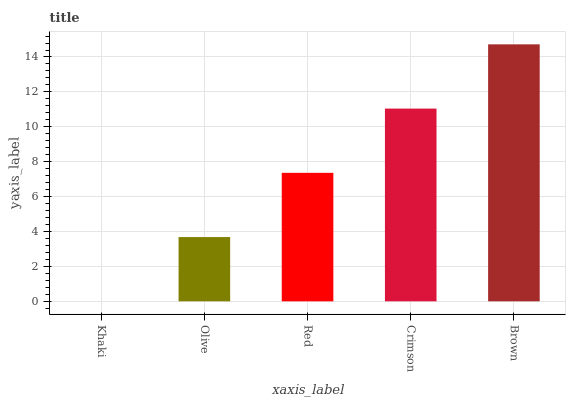Is Khaki the minimum?
Answer yes or no. Yes. Is Brown the maximum?
Answer yes or no. Yes. Is Olive the minimum?
Answer yes or no. No. Is Olive the maximum?
Answer yes or no. No. Is Olive greater than Khaki?
Answer yes or no. Yes. Is Khaki less than Olive?
Answer yes or no. Yes. Is Khaki greater than Olive?
Answer yes or no. No. Is Olive less than Khaki?
Answer yes or no. No. Is Red the high median?
Answer yes or no. Yes. Is Red the low median?
Answer yes or no. Yes. Is Olive the high median?
Answer yes or no. No. Is Khaki the low median?
Answer yes or no. No. 